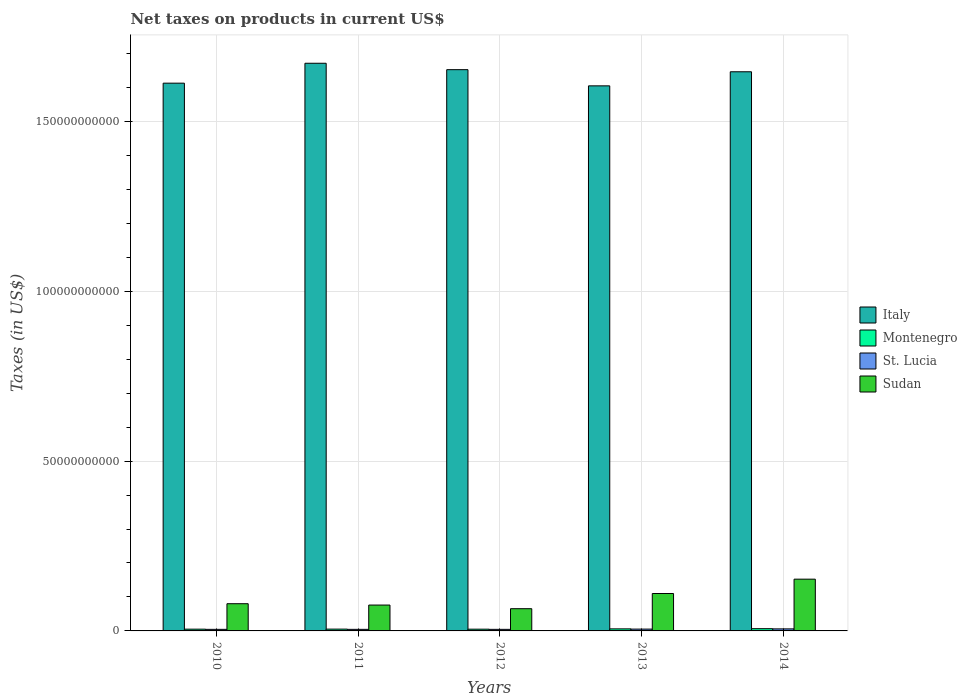Are the number of bars per tick equal to the number of legend labels?
Provide a succinct answer. Yes. How many bars are there on the 4th tick from the left?
Give a very brief answer. 4. What is the label of the 3rd group of bars from the left?
Offer a terse response. 2012. What is the net taxes on products in Italy in 2013?
Your response must be concise. 1.60e+11. Across all years, what is the maximum net taxes on products in Sudan?
Keep it short and to the point. 1.52e+1. Across all years, what is the minimum net taxes on products in Sudan?
Offer a terse response. 6.55e+09. In which year was the net taxes on products in Sudan maximum?
Keep it short and to the point. 2014. What is the total net taxes on products in Montenegro in the graph?
Offer a terse response. 2.82e+09. What is the difference between the net taxes on products in Montenegro in 2010 and that in 2013?
Offer a very short reply. -8.67e+07. What is the difference between the net taxes on products in Italy in 2010 and the net taxes on products in St. Lucia in 2013?
Your answer should be compact. 1.61e+11. What is the average net taxes on products in St. Lucia per year?
Give a very brief answer. 5.04e+08. In the year 2012, what is the difference between the net taxes on products in Italy and net taxes on products in Montenegro?
Your answer should be very brief. 1.65e+11. In how many years, is the net taxes on products in Italy greater than 160000000000 US$?
Provide a succinct answer. 5. What is the ratio of the net taxes on products in Montenegro in 2012 to that in 2013?
Ensure brevity in your answer.  0.85. Is the difference between the net taxes on products in Italy in 2011 and 2013 greater than the difference between the net taxes on products in Montenegro in 2011 and 2013?
Provide a succinct answer. Yes. What is the difference between the highest and the second highest net taxes on products in St. Lucia?
Ensure brevity in your answer.  6.52e+07. What is the difference between the highest and the lowest net taxes on products in Italy?
Your response must be concise. 6.65e+09. In how many years, is the net taxes on products in Italy greater than the average net taxes on products in Italy taken over all years?
Your answer should be very brief. 3. Is it the case that in every year, the sum of the net taxes on products in Italy and net taxes on products in St. Lucia is greater than the sum of net taxes on products in Montenegro and net taxes on products in Sudan?
Give a very brief answer. Yes. What does the 4th bar from the left in 2012 represents?
Offer a very short reply. Sudan. Is it the case that in every year, the sum of the net taxes on products in St. Lucia and net taxes on products in Montenegro is greater than the net taxes on products in Italy?
Offer a very short reply. No. How many bars are there?
Ensure brevity in your answer.  20. What is the difference between two consecutive major ticks on the Y-axis?
Provide a short and direct response. 5.00e+1. How many legend labels are there?
Your answer should be compact. 4. How are the legend labels stacked?
Your answer should be very brief. Vertical. What is the title of the graph?
Keep it short and to the point. Net taxes on products in current US$. Does "Central African Republic" appear as one of the legend labels in the graph?
Provide a short and direct response. No. What is the label or title of the X-axis?
Your response must be concise. Years. What is the label or title of the Y-axis?
Provide a succinct answer. Taxes (in US$). What is the Taxes (in US$) in Italy in 2010?
Your answer should be very brief. 1.61e+11. What is the Taxes (in US$) of Montenegro in 2010?
Offer a very short reply. 5.17e+08. What is the Taxes (in US$) of St. Lucia in 2010?
Your answer should be compact. 4.61e+08. What is the Taxes (in US$) of Sudan in 2010?
Offer a terse response. 8.01e+09. What is the Taxes (in US$) of Italy in 2011?
Provide a succinct answer. 1.67e+11. What is the Taxes (in US$) in Montenegro in 2011?
Offer a terse response. 5.29e+08. What is the Taxes (in US$) in St. Lucia in 2011?
Ensure brevity in your answer.  4.63e+08. What is the Taxes (in US$) of Sudan in 2011?
Your answer should be very brief. 7.62e+09. What is the Taxes (in US$) in Italy in 2012?
Your response must be concise. 1.65e+11. What is the Taxes (in US$) in Montenegro in 2012?
Your answer should be compact. 5.13e+08. What is the Taxes (in US$) of St. Lucia in 2012?
Offer a terse response. 4.62e+08. What is the Taxes (in US$) of Sudan in 2012?
Your answer should be compact. 6.55e+09. What is the Taxes (in US$) of Italy in 2013?
Keep it short and to the point. 1.60e+11. What is the Taxes (in US$) of Montenegro in 2013?
Offer a very short reply. 6.03e+08. What is the Taxes (in US$) in St. Lucia in 2013?
Give a very brief answer. 5.35e+08. What is the Taxes (in US$) of Sudan in 2013?
Your answer should be compact. 1.10e+1. What is the Taxes (in US$) of Italy in 2014?
Offer a terse response. 1.65e+11. What is the Taxes (in US$) in Montenegro in 2014?
Provide a short and direct response. 6.58e+08. What is the Taxes (in US$) of St. Lucia in 2014?
Ensure brevity in your answer.  6.00e+08. What is the Taxes (in US$) of Sudan in 2014?
Offer a very short reply. 1.52e+1. Across all years, what is the maximum Taxes (in US$) of Italy?
Your response must be concise. 1.67e+11. Across all years, what is the maximum Taxes (in US$) of Montenegro?
Your answer should be very brief. 6.58e+08. Across all years, what is the maximum Taxes (in US$) of St. Lucia?
Offer a very short reply. 6.00e+08. Across all years, what is the maximum Taxes (in US$) of Sudan?
Provide a succinct answer. 1.52e+1. Across all years, what is the minimum Taxes (in US$) in Italy?
Your answer should be compact. 1.60e+11. Across all years, what is the minimum Taxes (in US$) in Montenegro?
Your answer should be compact. 5.13e+08. Across all years, what is the minimum Taxes (in US$) in St. Lucia?
Offer a very short reply. 4.61e+08. Across all years, what is the minimum Taxes (in US$) in Sudan?
Make the answer very short. 6.55e+09. What is the total Taxes (in US$) of Italy in the graph?
Your answer should be very brief. 8.19e+11. What is the total Taxes (in US$) of Montenegro in the graph?
Make the answer very short. 2.82e+09. What is the total Taxes (in US$) of St. Lucia in the graph?
Offer a very short reply. 2.52e+09. What is the total Taxes (in US$) of Sudan in the graph?
Keep it short and to the point. 4.84e+1. What is the difference between the Taxes (in US$) of Italy in 2010 and that in 2011?
Your answer should be compact. -5.86e+09. What is the difference between the Taxes (in US$) in Montenegro in 2010 and that in 2011?
Make the answer very short. -1.28e+07. What is the difference between the Taxes (in US$) of St. Lucia in 2010 and that in 2011?
Your response must be concise. -1.84e+06. What is the difference between the Taxes (in US$) of Sudan in 2010 and that in 2011?
Offer a very short reply. 3.96e+08. What is the difference between the Taxes (in US$) in Italy in 2010 and that in 2012?
Provide a succinct answer. -3.98e+09. What is the difference between the Taxes (in US$) in Montenegro in 2010 and that in 2012?
Offer a terse response. 3.38e+06. What is the difference between the Taxes (in US$) of St. Lucia in 2010 and that in 2012?
Offer a very short reply. -1.08e+06. What is the difference between the Taxes (in US$) in Sudan in 2010 and that in 2012?
Offer a terse response. 1.47e+09. What is the difference between the Taxes (in US$) in Italy in 2010 and that in 2013?
Make the answer very short. 7.93e+08. What is the difference between the Taxes (in US$) of Montenegro in 2010 and that in 2013?
Your answer should be compact. -8.67e+07. What is the difference between the Taxes (in US$) in St. Lucia in 2010 and that in 2013?
Give a very brief answer. -7.41e+07. What is the difference between the Taxes (in US$) of Sudan in 2010 and that in 2013?
Give a very brief answer. -3.00e+09. What is the difference between the Taxes (in US$) of Italy in 2010 and that in 2014?
Your answer should be very brief. -3.36e+09. What is the difference between the Taxes (in US$) of Montenegro in 2010 and that in 2014?
Provide a succinct answer. -1.42e+08. What is the difference between the Taxes (in US$) in St. Lucia in 2010 and that in 2014?
Offer a terse response. -1.39e+08. What is the difference between the Taxes (in US$) of Sudan in 2010 and that in 2014?
Offer a terse response. -7.22e+09. What is the difference between the Taxes (in US$) of Italy in 2011 and that in 2012?
Offer a terse response. 1.88e+09. What is the difference between the Taxes (in US$) in Montenegro in 2011 and that in 2012?
Ensure brevity in your answer.  1.61e+07. What is the difference between the Taxes (in US$) of St. Lucia in 2011 and that in 2012?
Your response must be concise. 7.56e+05. What is the difference between the Taxes (in US$) of Sudan in 2011 and that in 2012?
Ensure brevity in your answer.  1.07e+09. What is the difference between the Taxes (in US$) in Italy in 2011 and that in 2013?
Your answer should be compact. 6.65e+09. What is the difference between the Taxes (in US$) of Montenegro in 2011 and that in 2013?
Your answer should be very brief. -7.39e+07. What is the difference between the Taxes (in US$) in St. Lucia in 2011 and that in 2013?
Your answer should be compact. -7.23e+07. What is the difference between the Taxes (in US$) in Sudan in 2011 and that in 2013?
Keep it short and to the point. -3.40e+09. What is the difference between the Taxes (in US$) of Italy in 2011 and that in 2014?
Make the answer very short. 2.51e+09. What is the difference between the Taxes (in US$) in Montenegro in 2011 and that in 2014?
Your answer should be very brief. -1.29e+08. What is the difference between the Taxes (in US$) in St. Lucia in 2011 and that in 2014?
Your response must be concise. -1.37e+08. What is the difference between the Taxes (in US$) in Sudan in 2011 and that in 2014?
Provide a succinct answer. -7.62e+09. What is the difference between the Taxes (in US$) in Italy in 2012 and that in 2013?
Your answer should be compact. 4.77e+09. What is the difference between the Taxes (in US$) in Montenegro in 2012 and that in 2013?
Your answer should be compact. -9.00e+07. What is the difference between the Taxes (in US$) in St. Lucia in 2012 and that in 2013?
Provide a succinct answer. -7.30e+07. What is the difference between the Taxes (in US$) in Sudan in 2012 and that in 2013?
Make the answer very short. -4.47e+09. What is the difference between the Taxes (in US$) in Italy in 2012 and that in 2014?
Your answer should be very brief. 6.21e+08. What is the difference between the Taxes (in US$) in Montenegro in 2012 and that in 2014?
Your answer should be very brief. -1.45e+08. What is the difference between the Taxes (in US$) in St. Lucia in 2012 and that in 2014?
Make the answer very short. -1.38e+08. What is the difference between the Taxes (in US$) in Sudan in 2012 and that in 2014?
Your answer should be compact. -8.69e+09. What is the difference between the Taxes (in US$) in Italy in 2013 and that in 2014?
Your response must be concise. -4.15e+09. What is the difference between the Taxes (in US$) in Montenegro in 2013 and that in 2014?
Offer a very short reply. -5.52e+07. What is the difference between the Taxes (in US$) of St. Lucia in 2013 and that in 2014?
Offer a very short reply. -6.52e+07. What is the difference between the Taxes (in US$) in Sudan in 2013 and that in 2014?
Offer a terse response. -4.22e+09. What is the difference between the Taxes (in US$) in Italy in 2010 and the Taxes (in US$) in Montenegro in 2011?
Your response must be concise. 1.61e+11. What is the difference between the Taxes (in US$) in Italy in 2010 and the Taxes (in US$) in St. Lucia in 2011?
Your response must be concise. 1.61e+11. What is the difference between the Taxes (in US$) in Italy in 2010 and the Taxes (in US$) in Sudan in 2011?
Ensure brevity in your answer.  1.54e+11. What is the difference between the Taxes (in US$) of Montenegro in 2010 and the Taxes (in US$) of St. Lucia in 2011?
Ensure brevity in your answer.  5.37e+07. What is the difference between the Taxes (in US$) of Montenegro in 2010 and the Taxes (in US$) of Sudan in 2011?
Your response must be concise. -7.10e+09. What is the difference between the Taxes (in US$) of St. Lucia in 2010 and the Taxes (in US$) of Sudan in 2011?
Make the answer very short. -7.16e+09. What is the difference between the Taxes (in US$) of Italy in 2010 and the Taxes (in US$) of Montenegro in 2012?
Offer a terse response. 1.61e+11. What is the difference between the Taxes (in US$) of Italy in 2010 and the Taxes (in US$) of St. Lucia in 2012?
Provide a succinct answer. 1.61e+11. What is the difference between the Taxes (in US$) in Italy in 2010 and the Taxes (in US$) in Sudan in 2012?
Your answer should be very brief. 1.55e+11. What is the difference between the Taxes (in US$) in Montenegro in 2010 and the Taxes (in US$) in St. Lucia in 2012?
Your answer should be compact. 5.45e+07. What is the difference between the Taxes (in US$) in Montenegro in 2010 and the Taxes (in US$) in Sudan in 2012?
Give a very brief answer. -6.03e+09. What is the difference between the Taxes (in US$) in St. Lucia in 2010 and the Taxes (in US$) in Sudan in 2012?
Your response must be concise. -6.08e+09. What is the difference between the Taxes (in US$) in Italy in 2010 and the Taxes (in US$) in Montenegro in 2013?
Offer a very short reply. 1.61e+11. What is the difference between the Taxes (in US$) in Italy in 2010 and the Taxes (in US$) in St. Lucia in 2013?
Offer a very short reply. 1.61e+11. What is the difference between the Taxes (in US$) of Italy in 2010 and the Taxes (in US$) of Sudan in 2013?
Give a very brief answer. 1.50e+11. What is the difference between the Taxes (in US$) in Montenegro in 2010 and the Taxes (in US$) in St. Lucia in 2013?
Your answer should be compact. -1.85e+07. What is the difference between the Taxes (in US$) of Montenegro in 2010 and the Taxes (in US$) of Sudan in 2013?
Ensure brevity in your answer.  -1.05e+1. What is the difference between the Taxes (in US$) of St. Lucia in 2010 and the Taxes (in US$) of Sudan in 2013?
Offer a very short reply. -1.06e+1. What is the difference between the Taxes (in US$) of Italy in 2010 and the Taxes (in US$) of Montenegro in 2014?
Your answer should be very brief. 1.61e+11. What is the difference between the Taxes (in US$) of Italy in 2010 and the Taxes (in US$) of St. Lucia in 2014?
Your answer should be compact. 1.61e+11. What is the difference between the Taxes (in US$) in Italy in 2010 and the Taxes (in US$) in Sudan in 2014?
Offer a terse response. 1.46e+11. What is the difference between the Taxes (in US$) in Montenegro in 2010 and the Taxes (in US$) in St. Lucia in 2014?
Ensure brevity in your answer.  -8.38e+07. What is the difference between the Taxes (in US$) in Montenegro in 2010 and the Taxes (in US$) in Sudan in 2014?
Give a very brief answer. -1.47e+1. What is the difference between the Taxes (in US$) of St. Lucia in 2010 and the Taxes (in US$) of Sudan in 2014?
Provide a succinct answer. -1.48e+1. What is the difference between the Taxes (in US$) in Italy in 2011 and the Taxes (in US$) in Montenegro in 2012?
Make the answer very short. 1.67e+11. What is the difference between the Taxes (in US$) of Italy in 2011 and the Taxes (in US$) of St. Lucia in 2012?
Offer a terse response. 1.67e+11. What is the difference between the Taxes (in US$) in Italy in 2011 and the Taxes (in US$) in Sudan in 2012?
Provide a short and direct response. 1.61e+11. What is the difference between the Taxes (in US$) of Montenegro in 2011 and the Taxes (in US$) of St. Lucia in 2012?
Keep it short and to the point. 6.72e+07. What is the difference between the Taxes (in US$) in Montenegro in 2011 and the Taxes (in US$) in Sudan in 2012?
Offer a very short reply. -6.02e+09. What is the difference between the Taxes (in US$) in St. Lucia in 2011 and the Taxes (in US$) in Sudan in 2012?
Make the answer very short. -6.08e+09. What is the difference between the Taxes (in US$) in Italy in 2011 and the Taxes (in US$) in Montenegro in 2013?
Your answer should be very brief. 1.67e+11. What is the difference between the Taxes (in US$) in Italy in 2011 and the Taxes (in US$) in St. Lucia in 2013?
Ensure brevity in your answer.  1.67e+11. What is the difference between the Taxes (in US$) in Italy in 2011 and the Taxes (in US$) in Sudan in 2013?
Your response must be concise. 1.56e+11. What is the difference between the Taxes (in US$) in Montenegro in 2011 and the Taxes (in US$) in St. Lucia in 2013?
Make the answer very short. -5.77e+06. What is the difference between the Taxes (in US$) of Montenegro in 2011 and the Taxes (in US$) of Sudan in 2013?
Provide a succinct answer. -1.05e+1. What is the difference between the Taxes (in US$) of St. Lucia in 2011 and the Taxes (in US$) of Sudan in 2013?
Keep it short and to the point. -1.06e+1. What is the difference between the Taxes (in US$) of Italy in 2011 and the Taxes (in US$) of Montenegro in 2014?
Keep it short and to the point. 1.66e+11. What is the difference between the Taxes (in US$) in Italy in 2011 and the Taxes (in US$) in St. Lucia in 2014?
Offer a terse response. 1.67e+11. What is the difference between the Taxes (in US$) in Italy in 2011 and the Taxes (in US$) in Sudan in 2014?
Your answer should be compact. 1.52e+11. What is the difference between the Taxes (in US$) in Montenegro in 2011 and the Taxes (in US$) in St. Lucia in 2014?
Provide a succinct answer. -7.10e+07. What is the difference between the Taxes (in US$) in Montenegro in 2011 and the Taxes (in US$) in Sudan in 2014?
Provide a short and direct response. -1.47e+1. What is the difference between the Taxes (in US$) in St. Lucia in 2011 and the Taxes (in US$) in Sudan in 2014?
Provide a short and direct response. -1.48e+1. What is the difference between the Taxes (in US$) of Italy in 2012 and the Taxes (in US$) of Montenegro in 2013?
Give a very brief answer. 1.65e+11. What is the difference between the Taxes (in US$) of Italy in 2012 and the Taxes (in US$) of St. Lucia in 2013?
Give a very brief answer. 1.65e+11. What is the difference between the Taxes (in US$) in Italy in 2012 and the Taxes (in US$) in Sudan in 2013?
Give a very brief answer. 1.54e+11. What is the difference between the Taxes (in US$) in Montenegro in 2012 and the Taxes (in US$) in St. Lucia in 2013?
Make the answer very short. -2.19e+07. What is the difference between the Taxes (in US$) of Montenegro in 2012 and the Taxes (in US$) of Sudan in 2013?
Provide a short and direct response. -1.05e+1. What is the difference between the Taxes (in US$) in St. Lucia in 2012 and the Taxes (in US$) in Sudan in 2013?
Provide a succinct answer. -1.06e+1. What is the difference between the Taxes (in US$) of Italy in 2012 and the Taxes (in US$) of Montenegro in 2014?
Provide a succinct answer. 1.65e+11. What is the difference between the Taxes (in US$) of Italy in 2012 and the Taxes (in US$) of St. Lucia in 2014?
Offer a very short reply. 1.65e+11. What is the difference between the Taxes (in US$) in Italy in 2012 and the Taxes (in US$) in Sudan in 2014?
Provide a succinct answer. 1.50e+11. What is the difference between the Taxes (in US$) of Montenegro in 2012 and the Taxes (in US$) of St. Lucia in 2014?
Your answer should be compact. -8.72e+07. What is the difference between the Taxes (in US$) in Montenegro in 2012 and the Taxes (in US$) in Sudan in 2014?
Provide a short and direct response. -1.47e+1. What is the difference between the Taxes (in US$) of St. Lucia in 2012 and the Taxes (in US$) of Sudan in 2014?
Your answer should be very brief. -1.48e+1. What is the difference between the Taxes (in US$) in Italy in 2013 and the Taxes (in US$) in Montenegro in 2014?
Provide a short and direct response. 1.60e+11. What is the difference between the Taxes (in US$) of Italy in 2013 and the Taxes (in US$) of St. Lucia in 2014?
Keep it short and to the point. 1.60e+11. What is the difference between the Taxes (in US$) of Italy in 2013 and the Taxes (in US$) of Sudan in 2014?
Your response must be concise. 1.45e+11. What is the difference between the Taxes (in US$) of Montenegro in 2013 and the Taxes (in US$) of St. Lucia in 2014?
Keep it short and to the point. 2.88e+06. What is the difference between the Taxes (in US$) in Montenegro in 2013 and the Taxes (in US$) in Sudan in 2014?
Provide a short and direct response. -1.46e+1. What is the difference between the Taxes (in US$) in St. Lucia in 2013 and the Taxes (in US$) in Sudan in 2014?
Offer a terse response. -1.47e+1. What is the average Taxes (in US$) of Italy per year?
Ensure brevity in your answer.  1.64e+11. What is the average Taxes (in US$) of Montenegro per year?
Offer a very short reply. 5.64e+08. What is the average Taxes (in US$) in St. Lucia per year?
Offer a terse response. 5.04e+08. What is the average Taxes (in US$) of Sudan per year?
Provide a succinct answer. 9.69e+09. In the year 2010, what is the difference between the Taxes (in US$) of Italy and Taxes (in US$) of Montenegro?
Your response must be concise. 1.61e+11. In the year 2010, what is the difference between the Taxes (in US$) of Italy and Taxes (in US$) of St. Lucia?
Make the answer very short. 1.61e+11. In the year 2010, what is the difference between the Taxes (in US$) in Italy and Taxes (in US$) in Sudan?
Offer a terse response. 1.53e+11. In the year 2010, what is the difference between the Taxes (in US$) in Montenegro and Taxes (in US$) in St. Lucia?
Give a very brief answer. 5.56e+07. In the year 2010, what is the difference between the Taxes (in US$) in Montenegro and Taxes (in US$) in Sudan?
Offer a very short reply. -7.50e+09. In the year 2010, what is the difference between the Taxes (in US$) of St. Lucia and Taxes (in US$) of Sudan?
Give a very brief answer. -7.55e+09. In the year 2011, what is the difference between the Taxes (in US$) of Italy and Taxes (in US$) of Montenegro?
Your answer should be compact. 1.67e+11. In the year 2011, what is the difference between the Taxes (in US$) in Italy and Taxes (in US$) in St. Lucia?
Ensure brevity in your answer.  1.67e+11. In the year 2011, what is the difference between the Taxes (in US$) of Italy and Taxes (in US$) of Sudan?
Keep it short and to the point. 1.60e+11. In the year 2011, what is the difference between the Taxes (in US$) in Montenegro and Taxes (in US$) in St. Lucia?
Keep it short and to the point. 6.65e+07. In the year 2011, what is the difference between the Taxes (in US$) in Montenegro and Taxes (in US$) in Sudan?
Give a very brief answer. -7.09e+09. In the year 2011, what is the difference between the Taxes (in US$) of St. Lucia and Taxes (in US$) of Sudan?
Give a very brief answer. -7.15e+09. In the year 2012, what is the difference between the Taxes (in US$) of Italy and Taxes (in US$) of Montenegro?
Give a very brief answer. 1.65e+11. In the year 2012, what is the difference between the Taxes (in US$) of Italy and Taxes (in US$) of St. Lucia?
Your answer should be compact. 1.65e+11. In the year 2012, what is the difference between the Taxes (in US$) in Italy and Taxes (in US$) in Sudan?
Provide a short and direct response. 1.59e+11. In the year 2012, what is the difference between the Taxes (in US$) of Montenegro and Taxes (in US$) of St. Lucia?
Give a very brief answer. 5.11e+07. In the year 2012, what is the difference between the Taxes (in US$) in Montenegro and Taxes (in US$) in Sudan?
Offer a terse response. -6.03e+09. In the year 2012, what is the difference between the Taxes (in US$) of St. Lucia and Taxes (in US$) of Sudan?
Your answer should be very brief. -6.08e+09. In the year 2013, what is the difference between the Taxes (in US$) in Italy and Taxes (in US$) in Montenegro?
Offer a terse response. 1.60e+11. In the year 2013, what is the difference between the Taxes (in US$) of Italy and Taxes (in US$) of St. Lucia?
Your answer should be compact. 1.60e+11. In the year 2013, what is the difference between the Taxes (in US$) of Italy and Taxes (in US$) of Sudan?
Your answer should be very brief. 1.49e+11. In the year 2013, what is the difference between the Taxes (in US$) in Montenegro and Taxes (in US$) in St. Lucia?
Offer a terse response. 6.81e+07. In the year 2013, what is the difference between the Taxes (in US$) of Montenegro and Taxes (in US$) of Sudan?
Your response must be concise. -1.04e+1. In the year 2013, what is the difference between the Taxes (in US$) of St. Lucia and Taxes (in US$) of Sudan?
Give a very brief answer. -1.05e+1. In the year 2014, what is the difference between the Taxes (in US$) of Italy and Taxes (in US$) of Montenegro?
Give a very brief answer. 1.64e+11. In the year 2014, what is the difference between the Taxes (in US$) of Italy and Taxes (in US$) of St. Lucia?
Your answer should be compact. 1.64e+11. In the year 2014, what is the difference between the Taxes (in US$) of Italy and Taxes (in US$) of Sudan?
Your answer should be compact. 1.49e+11. In the year 2014, what is the difference between the Taxes (in US$) of Montenegro and Taxes (in US$) of St. Lucia?
Offer a terse response. 5.81e+07. In the year 2014, what is the difference between the Taxes (in US$) of Montenegro and Taxes (in US$) of Sudan?
Ensure brevity in your answer.  -1.46e+1. In the year 2014, what is the difference between the Taxes (in US$) in St. Lucia and Taxes (in US$) in Sudan?
Offer a very short reply. -1.46e+1. What is the ratio of the Taxes (in US$) in Italy in 2010 to that in 2011?
Give a very brief answer. 0.96. What is the ratio of the Taxes (in US$) of Montenegro in 2010 to that in 2011?
Your answer should be very brief. 0.98. What is the ratio of the Taxes (in US$) in Sudan in 2010 to that in 2011?
Provide a succinct answer. 1.05. What is the ratio of the Taxes (in US$) of Italy in 2010 to that in 2012?
Provide a short and direct response. 0.98. What is the ratio of the Taxes (in US$) of Montenegro in 2010 to that in 2012?
Make the answer very short. 1.01. What is the ratio of the Taxes (in US$) of St. Lucia in 2010 to that in 2012?
Ensure brevity in your answer.  1. What is the ratio of the Taxes (in US$) of Sudan in 2010 to that in 2012?
Provide a succinct answer. 1.22. What is the ratio of the Taxes (in US$) in Montenegro in 2010 to that in 2013?
Provide a short and direct response. 0.86. What is the ratio of the Taxes (in US$) of St. Lucia in 2010 to that in 2013?
Provide a short and direct response. 0.86. What is the ratio of the Taxes (in US$) of Sudan in 2010 to that in 2013?
Offer a very short reply. 0.73. What is the ratio of the Taxes (in US$) of Italy in 2010 to that in 2014?
Offer a very short reply. 0.98. What is the ratio of the Taxes (in US$) of Montenegro in 2010 to that in 2014?
Make the answer very short. 0.78. What is the ratio of the Taxes (in US$) of St. Lucia in 2010 to that in 2014?
Keep it short and to the point. 0.77. What is the ratio of the Taxes (in US$) of Sudan in 2010 to that in 2014?
Provide a succinct answer. 0.53. What is the ratio of the Taxes (in US$) in Italy in 2011 to that in 2012?
Your answer should be very brief. 1.01. What is the ratio of the Taxes (in US$) of Montenegro in 2011 to that in 2012?
Provide a short and direct response. 1.03. What is the ratio of the Taxes (in US$) of St. Lucia in 2011 to that in 2012?
Provide a succinct answer. 1. What is the ratio of the Taxes (in US$) of Sudan in 2011 to that in 2012?
Give a very brief answer. 1.16. What is the ratio of the Taxes (in US$) in Italy in 2011 to that in 2013?
Offer a very short reply. 1.04. What is the ratio of the Taxes (in US$) in Montenegro in 2011 to that in 2013?
Give a very brief answer. 0.88. What is the ratio of the Taxes (in US$) of St. Lucia in 2011 to that in 2013?
Offer a very short reply. 0.86. What is the ratio of the Taxes (in US$) of Sudan in 2011 to that in 2013?
Keep it short and to the point. 0.69. What is the ratio of the Taxes (in US$) of Italy in 2011 to that in 2014?
Your response must be concise. 1.02. What is the ratio of the Taxes (in US$) of Montenegro in 2011 to that in 2014?
Provide a succinct answer. 0.8. What is the ratio of the Taxes (in US$) in St. Lucia in 2011 to that in 2014?
Offer a very short reply. 0.77. What is the ratio of the Taxes (in US$) of Sudan in 2011 to that in 2014?
Your response must be concise. 0.5. What is the ratio of the Taxes (in US$) in Italy in 2012 to that in 2013?
Provide a short and direct response. 1.03. What is the ratio of the Taxes (in US$) in Montenegro in 2012 to that in 2013?
Ensure brevity in your answer.  0.85. What is the ratio of the Taxes (in US$) of St. Lucia in 2012 to that in 2013?
Ensure brevity in your answer.  0.86. What is the ratio of the Taxes (in US$) in Sudan in 2012 to that in 2013?
Offer a very short reply. 0.59. What is the ratio of the Taxes (in US$) in Italy in 2012 to that in 2014?
Your response must be concise. 1. What is the ratio of the Taxes (in US$) of Montenegro in 2012 to that in 2014?
Make the answer very short. 0.78. What is the ratio of the Taxes (in US$) in St. Lucia in 2012 to that in 2014?
Your response must be concise. 0.77. What is the ratio of the Taxes (in US$) in Sudan in 2012 to that in 2014?
Make the answer very short. 0.43. What is the ratio of the Taxes (in US$) in Italy in 2013 to that in 2014?
Offer a terse response. 0.97. What is the ratio of the Taxes (in US$) of Montenegro in 2013 to that in 2014?
Offer a terse response. 0.92. What is the ratio of the Taxes (in US$) of St. Lucia in 2013 to that in 2014?
Offer a very short reply. 0.89. What is the ratio of the Taxes (in US$) in Sudan in 2013 to that in 2014?
Your response must be concise. 0.72. What is the difference between the highest and the second highest Taxes (in US$) in Italy?
Provide a short and direct response. 1.88e+09. What is the difference between the highest and the second highest Taxes (in US$) in Montenegro?
Provide a succinct answer. 5.52e+07. What is the difference between the highest and the second highest Taxes (in US$) in St. Lucia?
Provide a short and direct response. 6.52e+07. What is the difference between the highest and the second highest Taxes (in US$) of Sudan?
Provide a succinct answer. 4.22e+09. What is the difference between the highest and the lowest Taxes (in US$) of Italy?
Your answer should be compact. 6.65e+09. What is the difference between the highest and the lowest Taxes (in US$) of Montenegro?
Your answer should be compact. 1.45e+08. What is the difference between the highest and the lowest Taxes (in US$) of St. Lucia?
Offer a very short reply. 1.39e+08. What is the difference between the highest and the lowest Taxes (in US$) in Sudan?
Offer a terse response. 8.69e+09. 